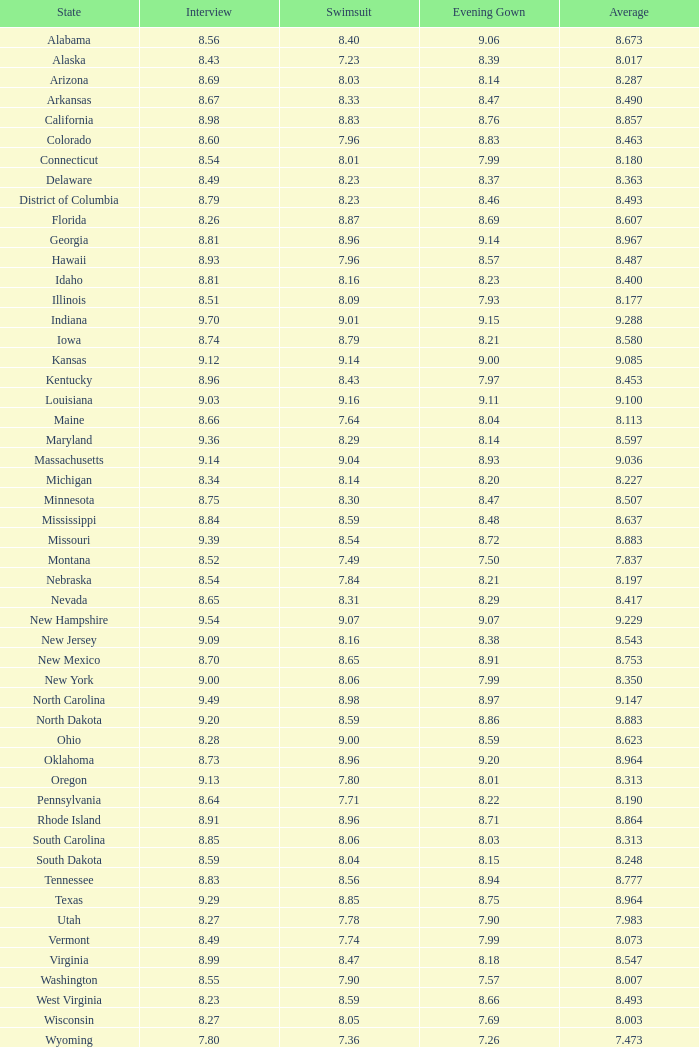7 and bathing suit under Alabama. 